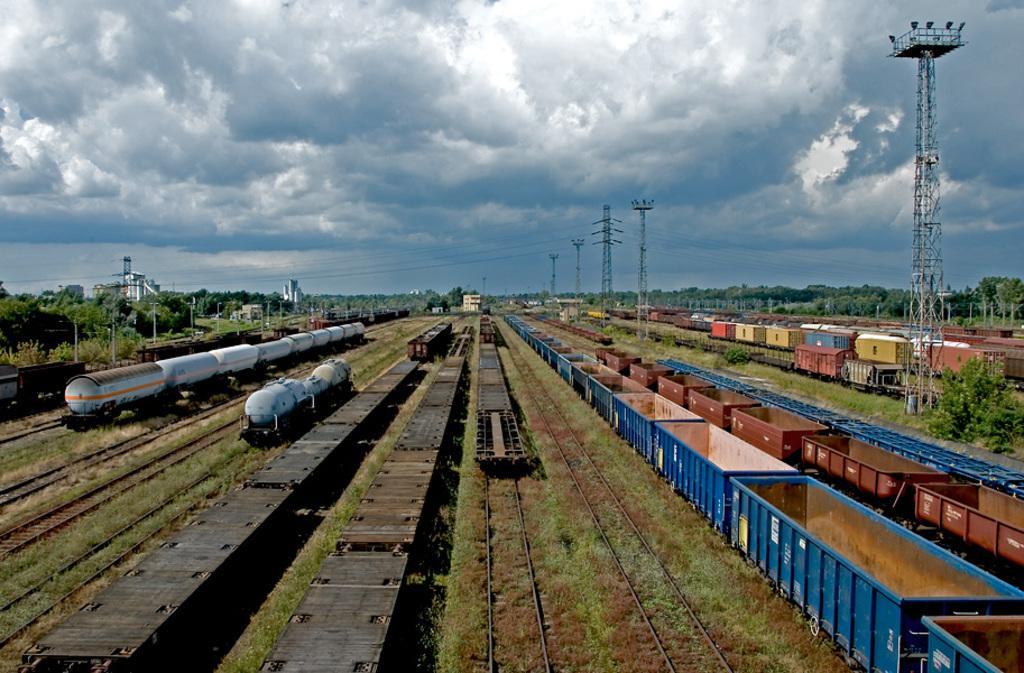Can you describe this image briefly? This picture is consists of docks in the image and there are towers in the image, there are trees and buildings in the background area of the image, there is grassland in between tracks. 